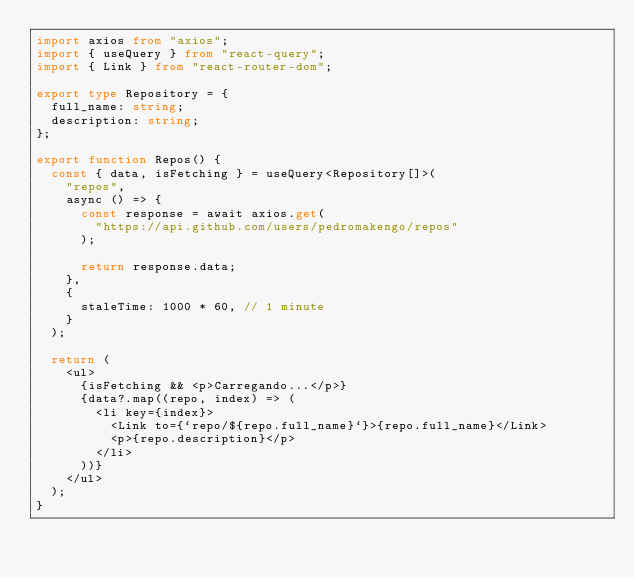<code> <loc_0><loc_0><loc_500><loc_500><_TypeScript_>import axios from "axios";
import { useQuery } from "react-query";
import { Link } from "react-router-dom";

export type Repository = {
  full_name: string;
  description: string;
};

export function Repos() {
  const { data, isFetching } = useQuery<Repository[]>(
    "repos",
    async () => {
      const response = await axios.get(
        "https://api.github.com/users/pedromakengo/repos"
      );

      return response.data;
    },
    {
      staleTime: 1000 * 60, // 1 minute
    }
  );

  return (
    <ul>
      {isFetching && <p>Carregando...</p>}
      {data?.map((repo, index) => (
        <li key={index}>
          <Link to={`repo/${repo.full_name}`}>{repo.full_name}</Link>
          <p>{repo.description}</p>
        </li>
      ))}
    </ul>
  );
}
</code> 